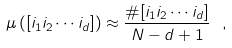<formula> <loc_0><loc_0><loc_500><loc_500>\mu \left ( [ i _ { 1 } i _ { 2 } \cdots i _ { d } ] \right ) \approx \frac { \# [ i _ { 1 } i _ { 2 } \cdots i _ { d } ] } { N - d + 1 } \ ,</formula> 